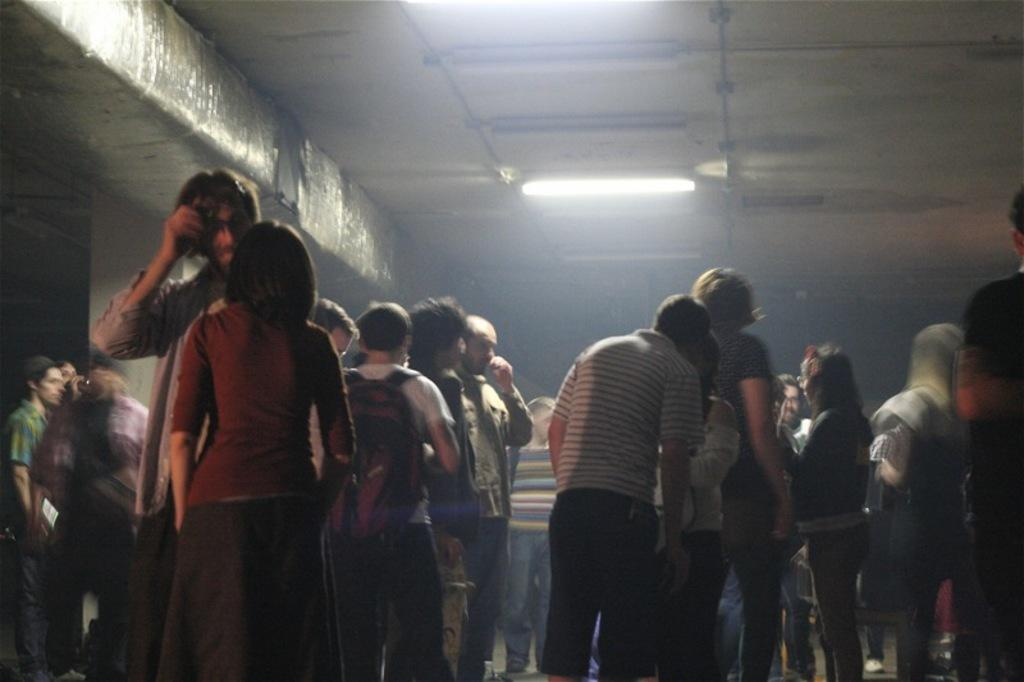How many people are in the image? There is a group of people in the image, but the exact number cannot be determined from the provided facts. What is located behind the group of people? There is a wall in the image. What can be seen illuminating the scene? There is a light in the image. What type of eggnog is being served in the image? There is no mention of eggnog or any beverage in the image. How many bags are visible in the image? There is no mention of bags or any similar objects in the image. 